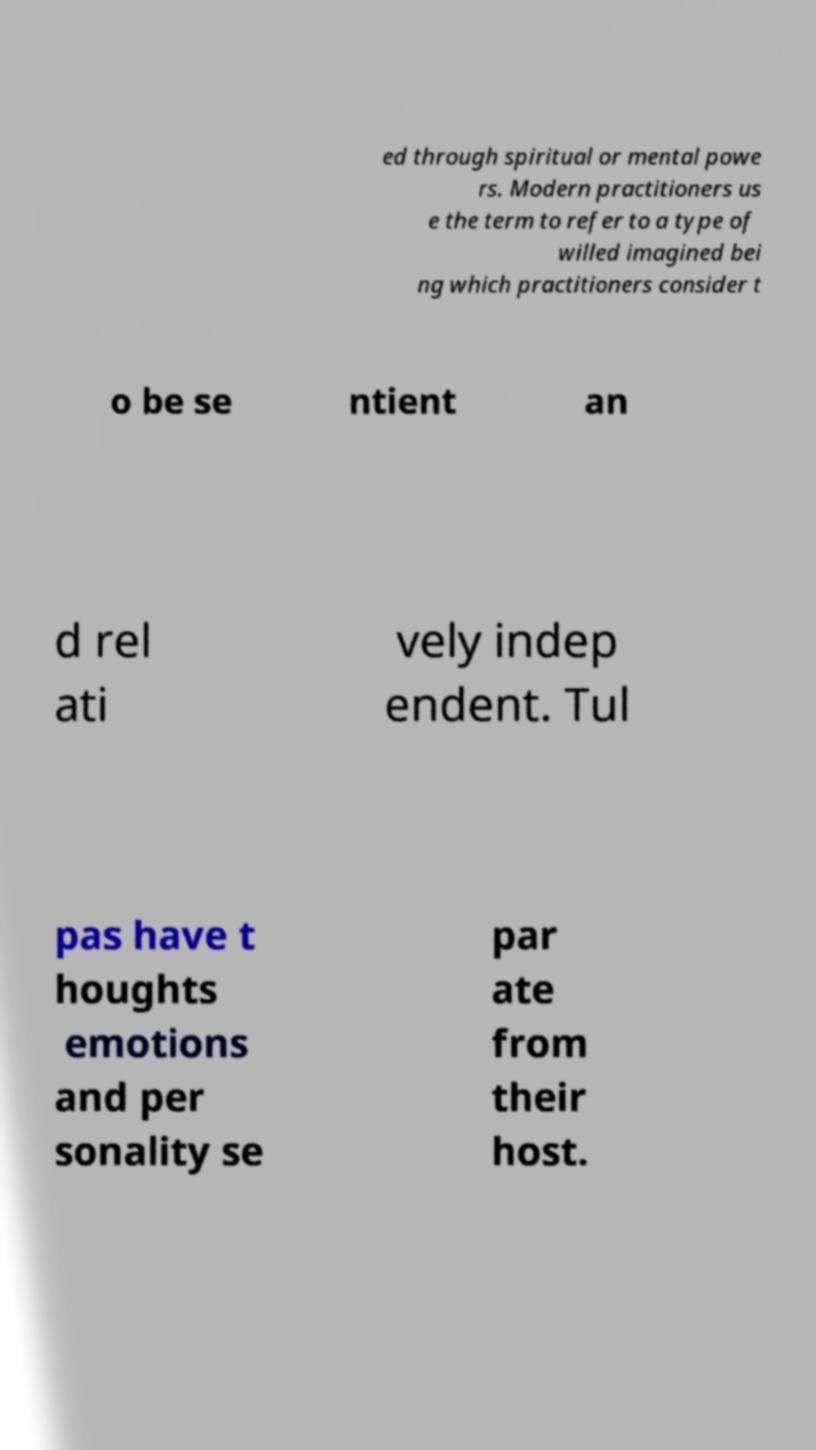Please identify and transcribe the text found in this image. ed through spiritual or mental powe rs. Modern practitioners us e the term to refer to a type of willed imagined bei ng which practitioners consider t o be se ntient an d rel ati vely indep endent. Tul pas have t houghts emotions and per sonality se par ate from their host. 